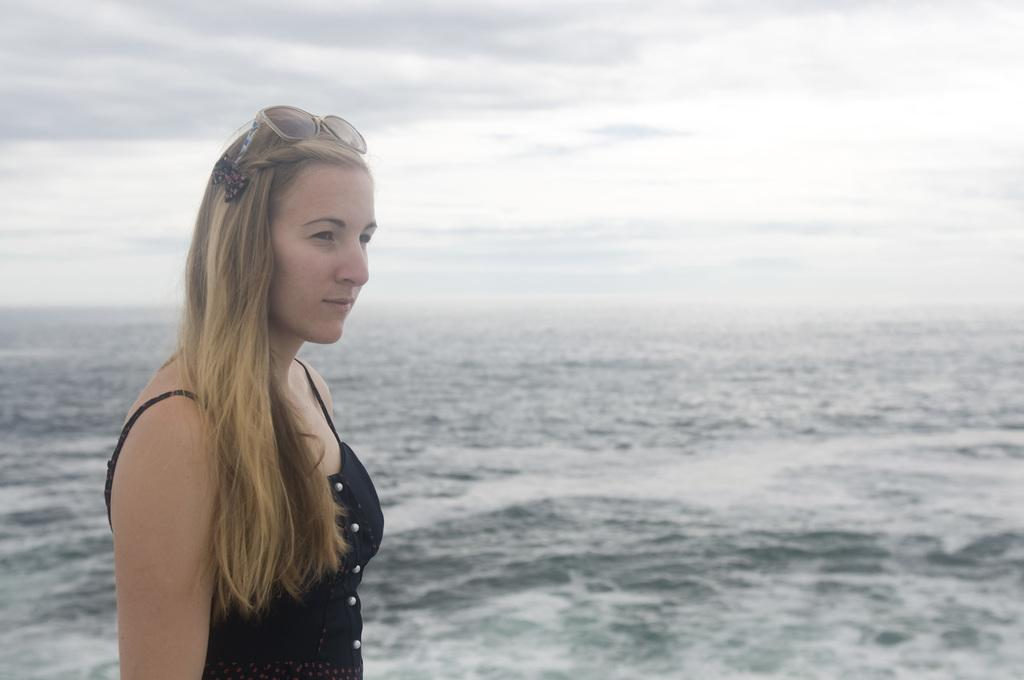What is the main subject of the image? There is a lady standing in the image. What is the lady wearing? The lady is wearing a black dress. What can be seen in the background of the image? There is a sea and the sky visible in the background of the image. What type of bone is the lady holding in the image? There is no bone present in the image; the lady is not holding anything. Can you see any army personnel in the image? There is no army personnel visible in the image; it only features a lady standing. 